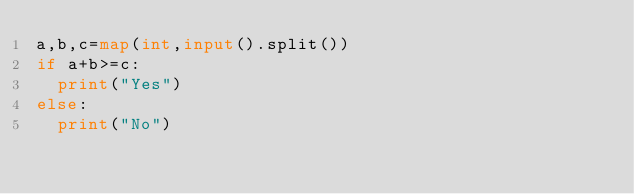Convert code to text. <code><loc_0><loc_0><loc_500><loc_500><_Python_>a,b,c=map(int,input().split())
if a+b>=c:
  print("Yes")
else:
  print("No")</code> 